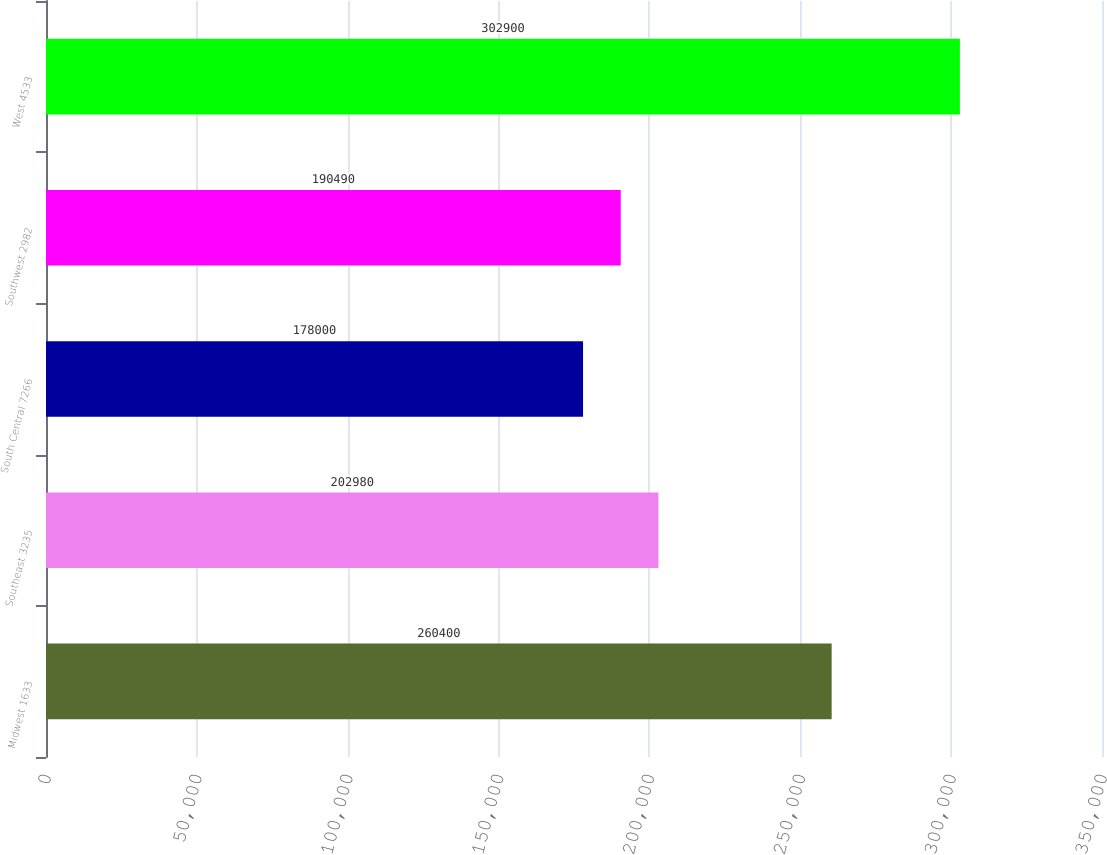Convert chart. <chart><loc_0><loc_0><loc_500><loc_500><bar_chart><fcel>Midwest 1633<fcel>Southeast 3235<fcel>South Central 7266<fcel>Southwest 2982<fcel>West 4533<nl><fcel>260400<fcel>202980<fcel>178000<fcel>190490<fcel>302900<nl></chart> 